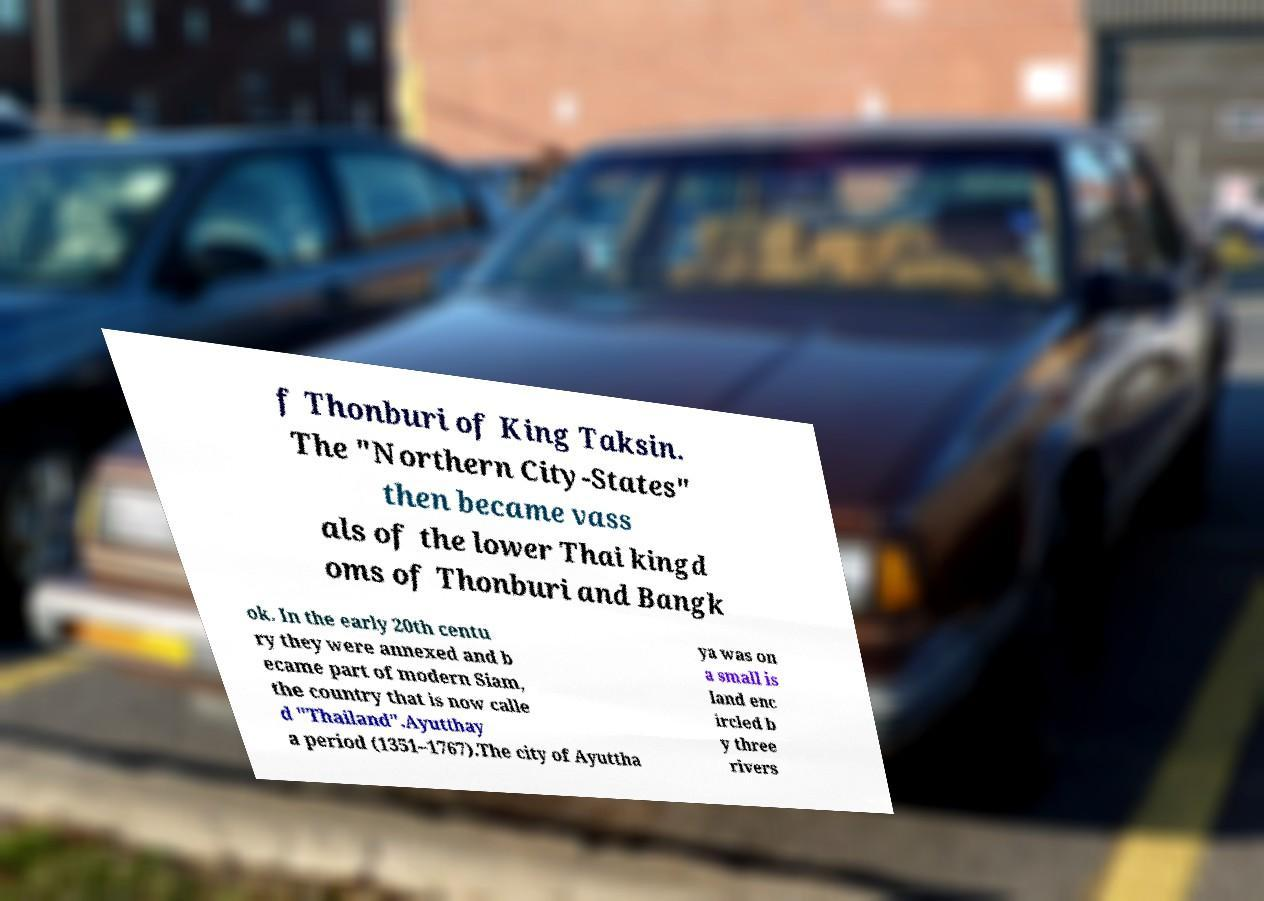Please read and relay the text visible in this image. What does it say? f Thonburi of King Taksin. The "Northern City-States" then became vass als of the lower Thai kingd oms of Thonburi and Bangk ok. In the early 20th centu ry they were annexed and b ecame part of modern Siam, the country that is now calle d "Thailand".Ayutthay a period (1351–1767).The city of Ayuttha ya was on a small is land enc ircled b y three rivers 